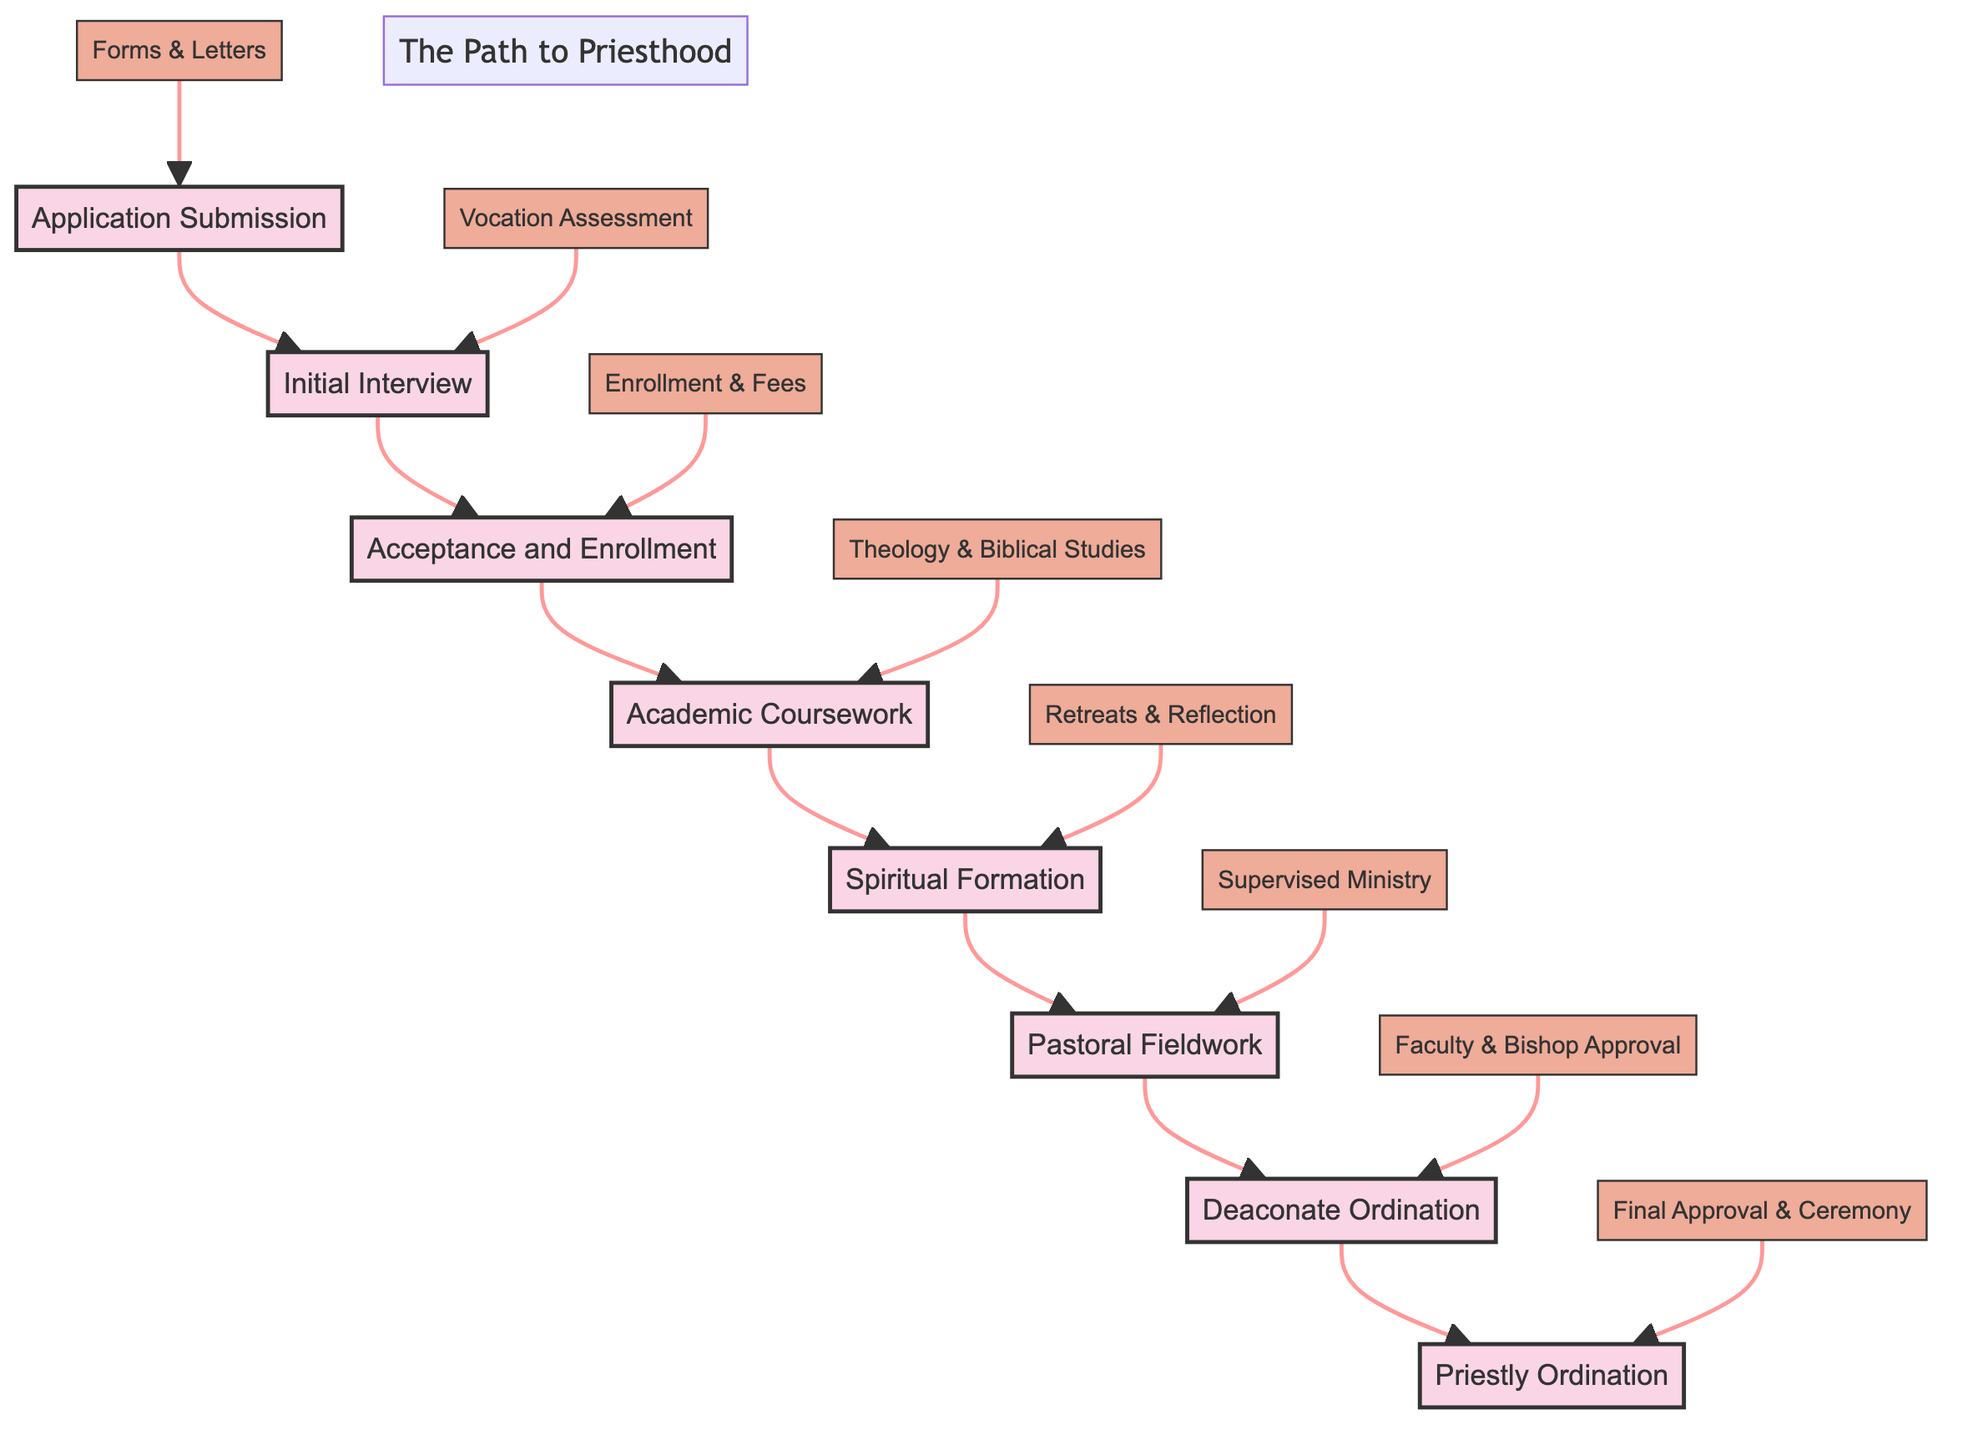What is the first step in the path to becoming ordained? The first step in the flowchart is "Application Submission." This can be determined by looking at the diagram's structure, where "Application Submission" is located at the bottom, indicating it is the starting point of the process.
Answer: Application Submission How many stages are in the journey to ordination? Counting the nodes in the diagram, there are eight stages: Application Submission, Initial Interview, Acceptance and Enrollment, Academic Coursework, Spiritual Formation, Pastoral Fieldwork, Deaconate Ordination, and Priestly Ordination.
Answer: Eight What follows the Initial Interview? Following the "Initial Interview," the next step in the flow is "Acceptance and Enrollment." This is derived from the arrow that connects "Initial Interview" directly to "Acceptance and Enrollment" in the diagram.
Answer: Acceptance and Enrollment What are the requirements for Deaconate Ordination? The requirements for "Deaconate Ordination" are three items listed: Completion of Coursework, Approval from Seminary Faculty, and Bishop’s Approval. These can be found connected to the "Deaconate Ordination" node in the diagram.
Answer: Completion of Coursework, Approval from Seminary Faculty, Bishop’s Approval What is the final stage in the path to becoming ordained? The final stage is "Priestly Ordination," which is indicated by its position at the top of the diagram, being the last step in the flow.
Answer: Priestly Ordination Which stage requires a local parish placement? "Pastoral Fieldwork" is the stage that requires a local parish placement. This requirement is explicitly stated under the "Pastoral Fieldwork" node in the flowchart.
Answer: Pastoral Fieldwork What step involves academic coursework? The step that involves academic coursework is "Academic Coursework," which is clearly indicated in the diagram as one of the stages in the flow toward ordination.
Answer: Academic Coursework How many requirements are listed for the Academic Coursework stage? There are four requirements listed for the "Academic Coursework" stage, which include Theology Courses, Biblical Studies, Church History, and Moral Theology. These are detailed under the "Academic Coursework" node in the flowchart.
Answer: Four 